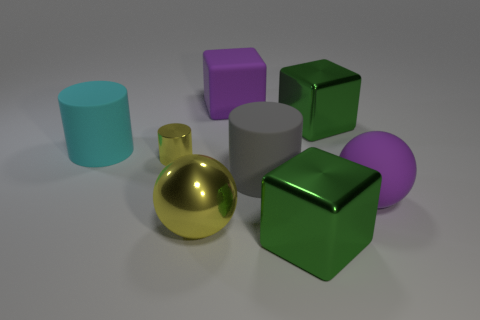Does the big matte block have the same color as the large rubber sphere? Yes, both the big matte block and the large rubber sphere share a similar shade of green, although the lighting and surface texture may affect their appearance. 